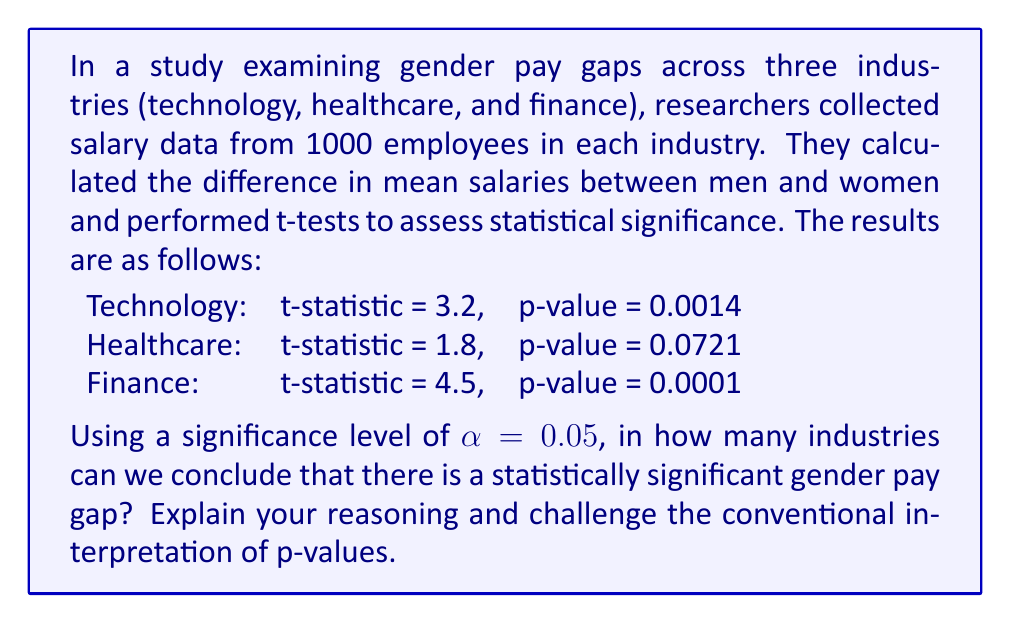Could you help me with this problem? To answer this question, we need to follow these steps:

1. Understand the concept of statistical significance:
   - A result is considered statistically significant if the p-value is less than the chosen significance level (α).
   - In this case, α = 0.05.

2. Compare each industry's p-value to the significance level:
   - Technology: p-value (0.0014) < α (0.05)
   - Healthcare: p-value (0.0721) > α (0.05)
   - Finance: p-value (0.0001) < α (0.05)

3. Count the number of industries with statistically significant results:
   - Technology and Finance have p-values less than 0.05, so there are 2 industries with statistically significant gender pay gaps.

4. Critical thinking and challenging authority:
   While the conventional interpretation suggests that we can conclude there is a statistically significant gender pay gap in 2 industries, it's important to question this approach:

   a) P-values don't measure the size or practical importance of an effect, only the probability of observing such data given the null hypothesis is true.
   
   b) The arbitrary threshold of 0.05 is not a scientific law. Healthcare's p-value (0.0721) is close to 0.05, and the difference between 0.0721 and 0.05 may not be meaningful in practical terms.
   
   c) Statistical significance doesn't always imply practical significance. We should consider the effect size (the magnitude of the salary difference) alongside the p-value.
   
   d) Multiple comparisons increase the risk of Type I errors. When testing multiple hypotheses, the chance of finding at least one "significant" result increases, even if all null hypotheses are true.

   e) Large sample sizes (1000 per industry) can lead to statistically significant results for even tiny, practically insignificant differences.

Therefore, while the conventional answer is 2, a more nuanced approach would involve:
1. Examining effect sizes alongside p-values.
2. Considering practical significance in addition to statistical significance.
3. Adjusting for multiple comparisons (e.g., using the Bonferroni correction).
4. Investigating potential confounding variables that might explain the observed differences.
Answer: 2 industries, but this interpretation should be critically examined. 